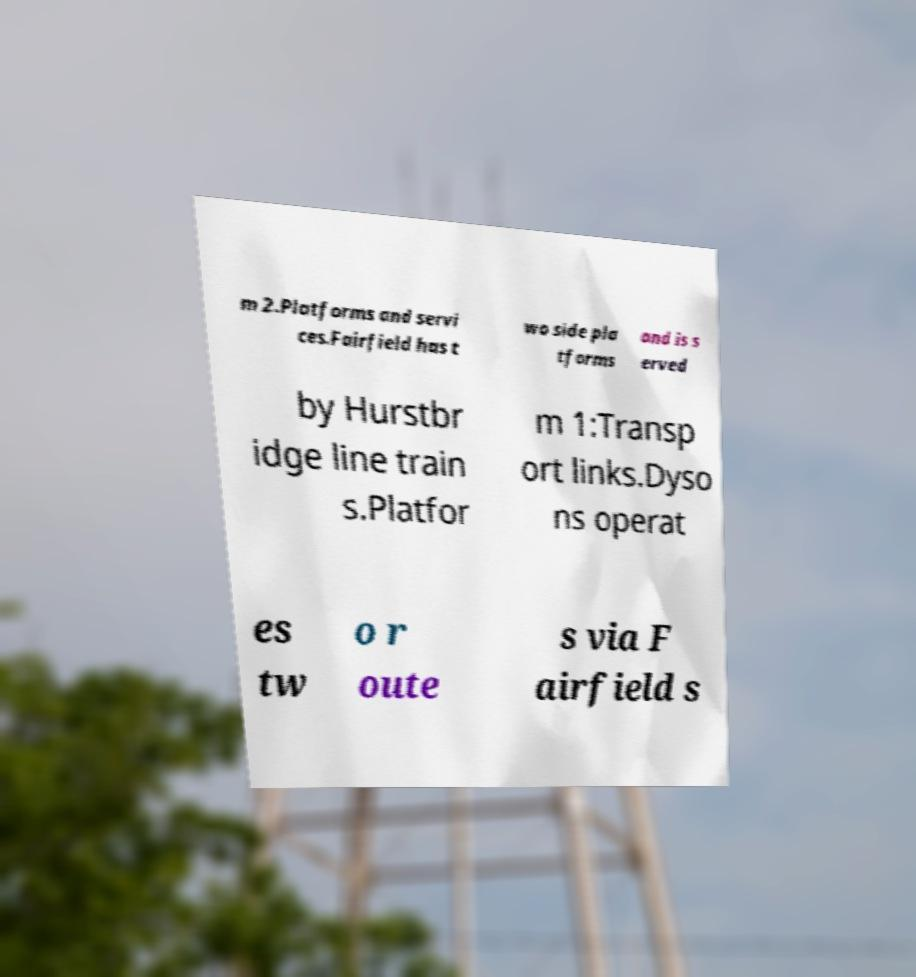For documentation purposes, I need the text within this image transcribed. Could you provide that? m 2.Platforms and servi ces.Fairfield has t wo side pla tforms and is s erved by Hurstbr idge line train s.Platfor m 1:Transp ort links.Dyso ns operat es tw o r oute s via F airfield s 